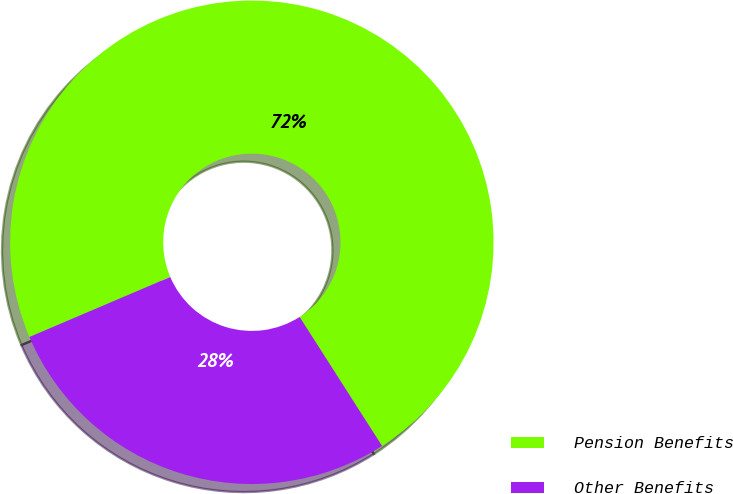Convert chart. <chart><loc_0><loc_0><loc_500><loc_500><pie_chart><fcel>Pension Benefits<fcel>Other Benefits<nl><fcel>72.36%<fcel>27.64%<nl></chart> 